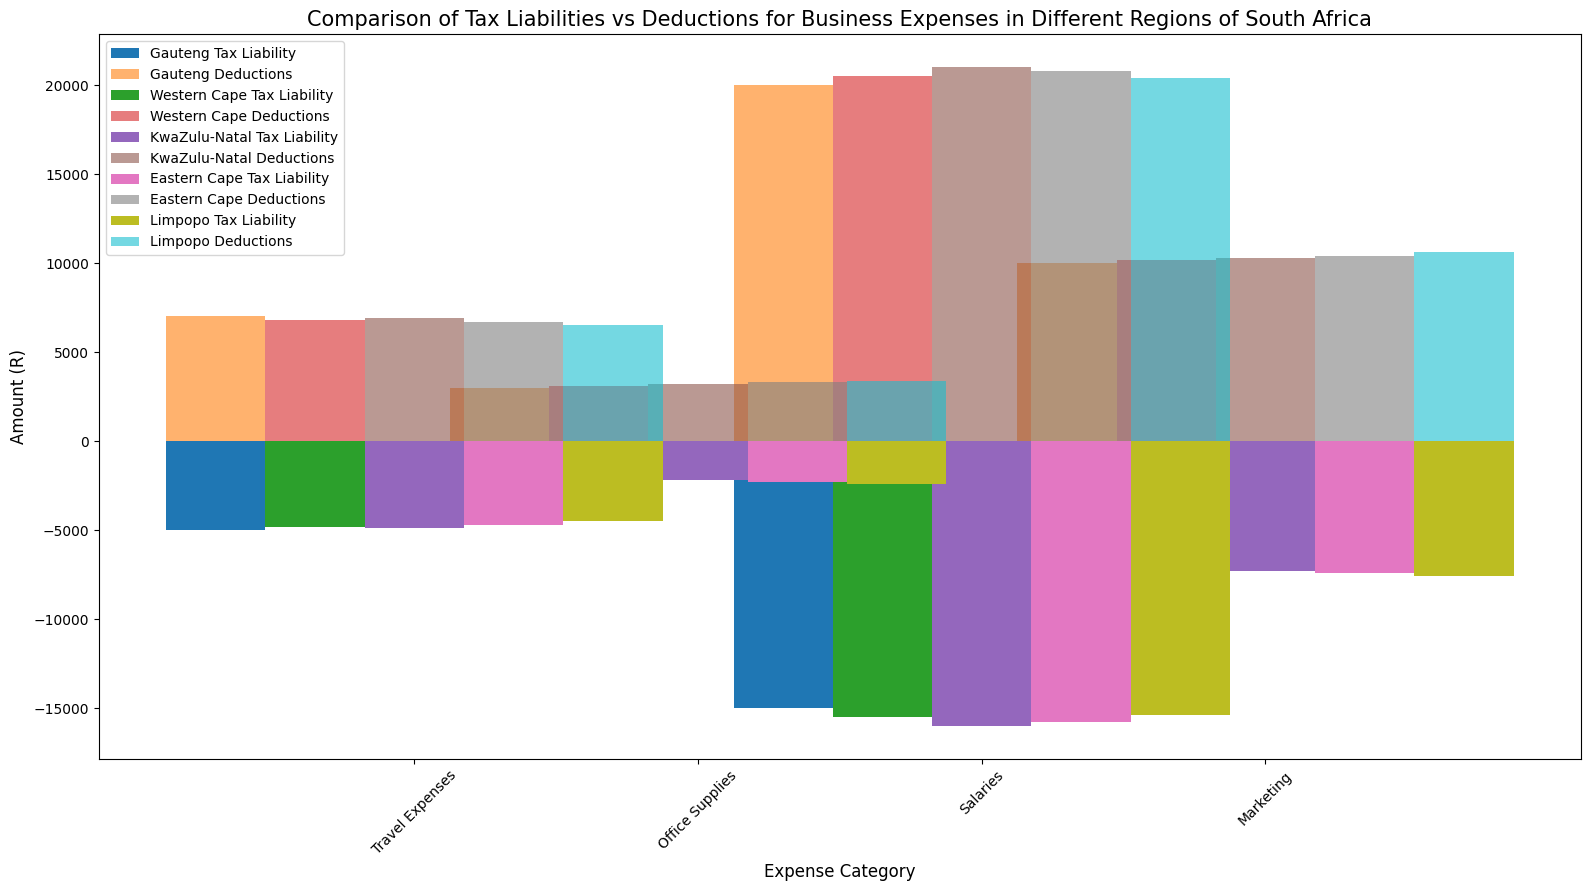Which region has the highest deductions for Salaries? To determine the region with the highest deductions for Salaries, look for the tallest bar in the Salaries category for deductions. The tallest bar is in the Western Cape region.
Answer: Western Cape How much more are the deductions for Marketing in Limpopo compared to Gauteng? First, identify the bars representing deductions for Marketing in both Limpopo and Gauteng. Limpopo deductions for Marketing are 10600 and Gauteng deductions for Marketing are 10000. Subtract to find the difference: 10600 - 10000 = 600.
Answer: 600 What is the sum of the Tax Liabilities for Travel Expenses in Western Cape and Eastern Cape? Find the bars representing Tax Liabilities for Travel Expenses in both Western Cape and Eastern Cape. Western Cape is -4800, and Eastern Cape is -4700. Sum these values: -4800 + (-4700) = -9500.
Answer: -9500 Which region has the smallest deductions for Office Supplies? Compare the heights of the bars representing deductions for Office Supplies across all regions. The shortest bar is for KwaZulu-Natal.
Answer: KwaZulu-Natal In which region is the difference between Deductions and Tax Liability for Office Supplies the greatest? Calculate the difference (Deductions - Tax Liability) for Office Supplies in each region. You find the maximum difference in Limpopo: Deductions (3400) - Tax Liability (-2400) = 5800.
Answer: Limpopo Which expense category in Gauteng has the highest tax liability? Look at the bars representing tax liabilities in Gauteng for all expense categories. The highest tax liability bar is for Salaries, with a value of -15000.
Answer: Salaries What is the average deduction for Travel Expenses across all regions? Add up the deductions for Travel Expenses in all regions: 7000 (Gauteng) + 6800 (Western Cape) + 6900 (KwaZulu-Natal) + 6700 (Eastern Cape) + 6500 (Limpopo) = 33900. Divide by the number of regions: 33900 / 5 = 6780.
Answer: 6780 How does the tax liability for Marketing compare between KwaZulu-Natal and Eastern Cape? Look at the bars representing tax liability for Marketing in both KwaZulu-Natal and Eastern Cape. KwaZulu-Natal has -7300, and Eastern Cape has -7400. KwaZulu-Natal's tax liability is 100 units less.
Answer: Less by 100 